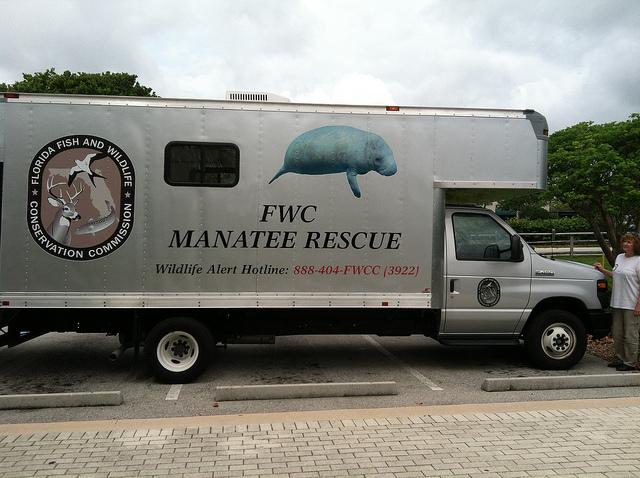Who is in the photo?
Concise answer only. Woman. What color is the truck?
Short answer required. Silver. Is it snowing?
Short answer required. No. 